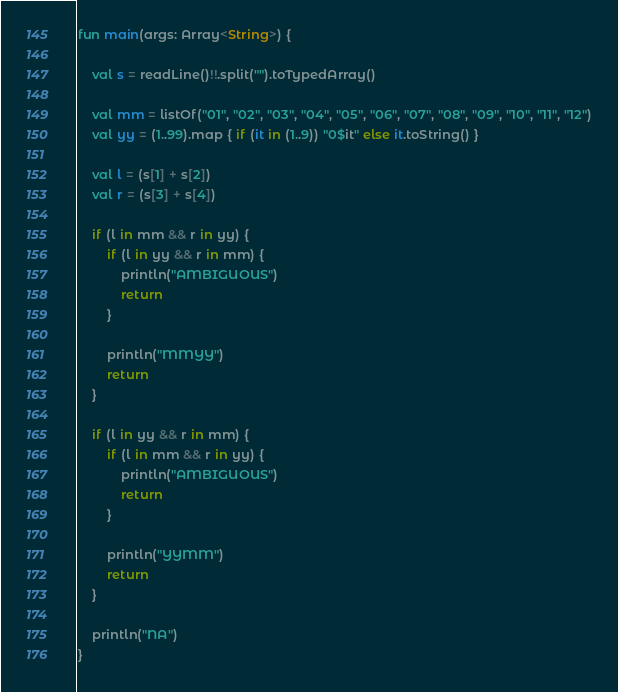<code> <loc_0><loc_0><loc_500><loc_500><_Kotlin_>fun main(args: Array<String>) {

    val s = readLine()!!.split("").toTypedArray()

    val mm = listOf("01", "02", "03", "04", "05", "06", "07", "08", "09", "10", "11", "12")
    val yy = (1..99).map { if (it in (1..9)) "0$it" else it.toString() }

    val l = (s[1] + s[2])
    val r = (s[3] + s[4])

    if (l in mm && r in yy) {
        if (l in yy && r in mm) {
            println("AMBIGUOUS")
            return
        }

        println("MMYY")
        return
    }

    if (l in yy && r in mm) {
        if (l in mm && r in yy) {
            println("AMBIGUOUS")
            return
        }

        println("YYMM")
        return
    }

    println("NA")
}
</code> 